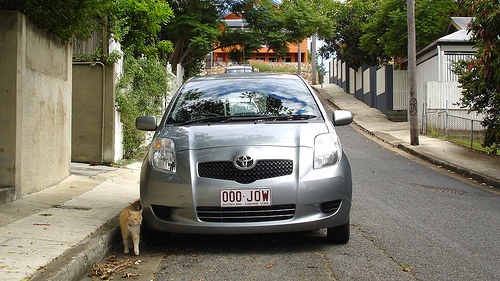<image>
Is there a building above the car? No. The building is not positioned above the car. The vertical arrangement shows a different relationship. 